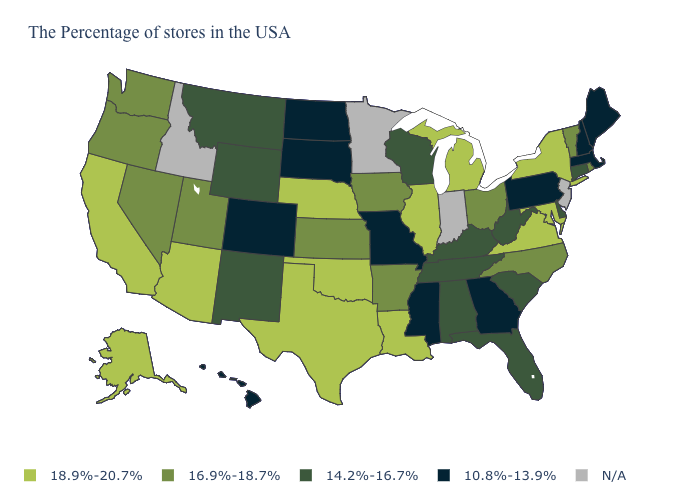What is the highest value in the USA?
Answer briefly. 18.9%-20.7%. Which states hav the highest value in the Northeast?
Be succinct. New York. What is the value of West Virginia?
Quick response, please. 14.2%-16.7%. Name the states that have a value in the range 10.8%-13.9%?
Keep it brief. Maine, Massachusetts, New Hampshire, Pennsylvania, Georgia, Mississippi, Missouri, South Dakota, North Dakota, Colorado, Hawaii. Does the map have missing data?
Give a very brief answer. Yes. What is the value of Utah?
Give a very brief answer. 16.9%-18.7%. What is the value of Louisiana?
Quick response, please. 18.9%-20.7%. Among the states that border Iowa , which have the lowest value?
Write a very short answer. Missouri, South Dakota. What is the highest value in states that border Idaho?
Quick response, please. 16.9%-18.7%. Does New York have the highest value in the Northeast?
Answer briefly. Yes. What is the value of Nevada?
Short answer required. 16.9%-18.7%. Name the states that have a value in the range 18.9%-20.7%?
Quick response, please. New York, Maryland, Virginia, Michigan, Illinois, Louisiana, Nebraska, Oklahoma, Texas, Arizona, California, Alaska. Name the states that have a value in the range 10.8%-13.9%?
Answer briefly. Maine, Massachusetts, New Hampshire, Pennsylvania, Georgia, Mississippi, Missouri, South Dakota, North Dakota, Colorado, Hawaii. 